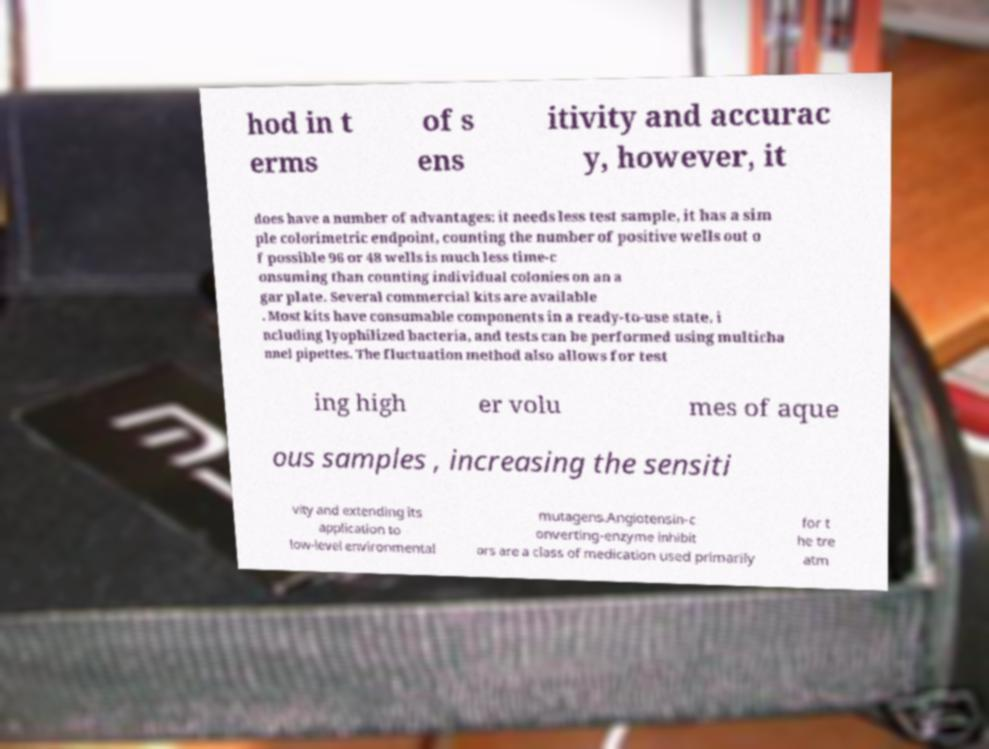Please identify and transcribe the text found in this image. hod in t erms of s ens itivity and accurac y, however, it does have a number of advantages: it needs less test sample, it has a sim ple colorimetric endpoint, counting the number of positive wells out o f possible 96 or 48 wells is much less time-c onsuming than counting individual colonies on an a gar plate. Several commercial kits are available . Most kits have consumable components in a ready-to-use state, i ncluding lyophilized bacteria, and tests can be performed using multicha nnel pipettes. The fluctuation method also allows for test ing high er volu mes of aque ous samples , increasing the sensiti vity and extending its application to low-level environmental mutagens.Angiotensin-c onverting-enzyme inhibit ors are a class of medication used primarily for t he tre atm 